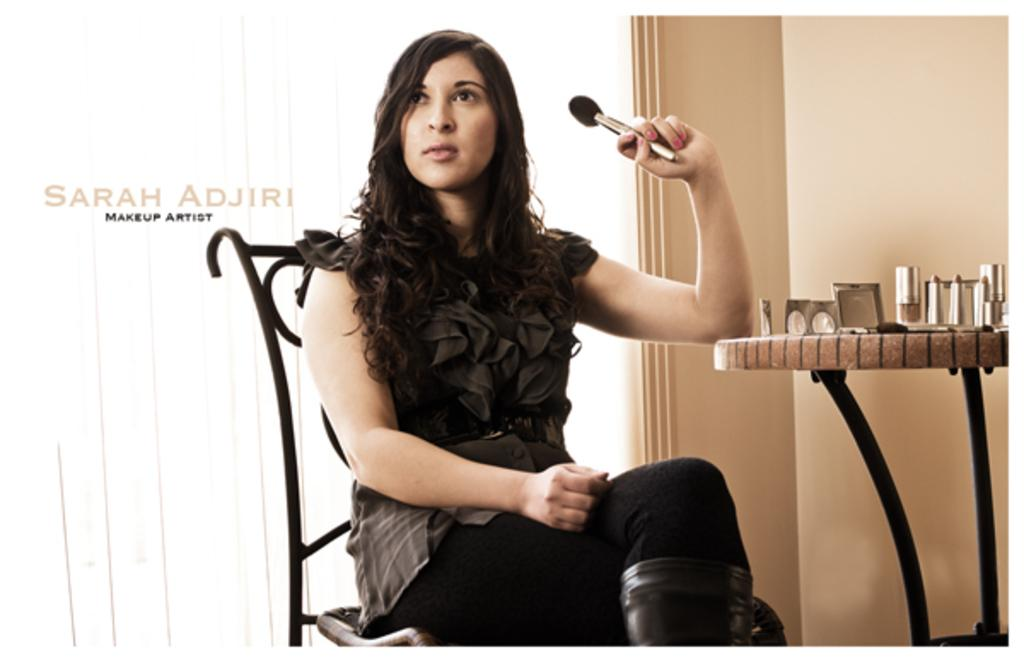Who is present in the image? There is a woman in the image. What is the woman doing in the image? The woman is sitting on a chair. What is the woman holding in her hand? The woman is holding a makeup brush in her hand. What can be seen on the right side of the image? There is a table on the right side of the image. What is placed on the table? Makeup items are placed on the table. What type of turkey is being prepared on the table in the image? There is no turkey present in the image; it features a woman sitting on a chair with makeup items on a table. What color is the woman's underwear in the image? The image does not show the woman's underwear, so it cannot be determined from the image. 